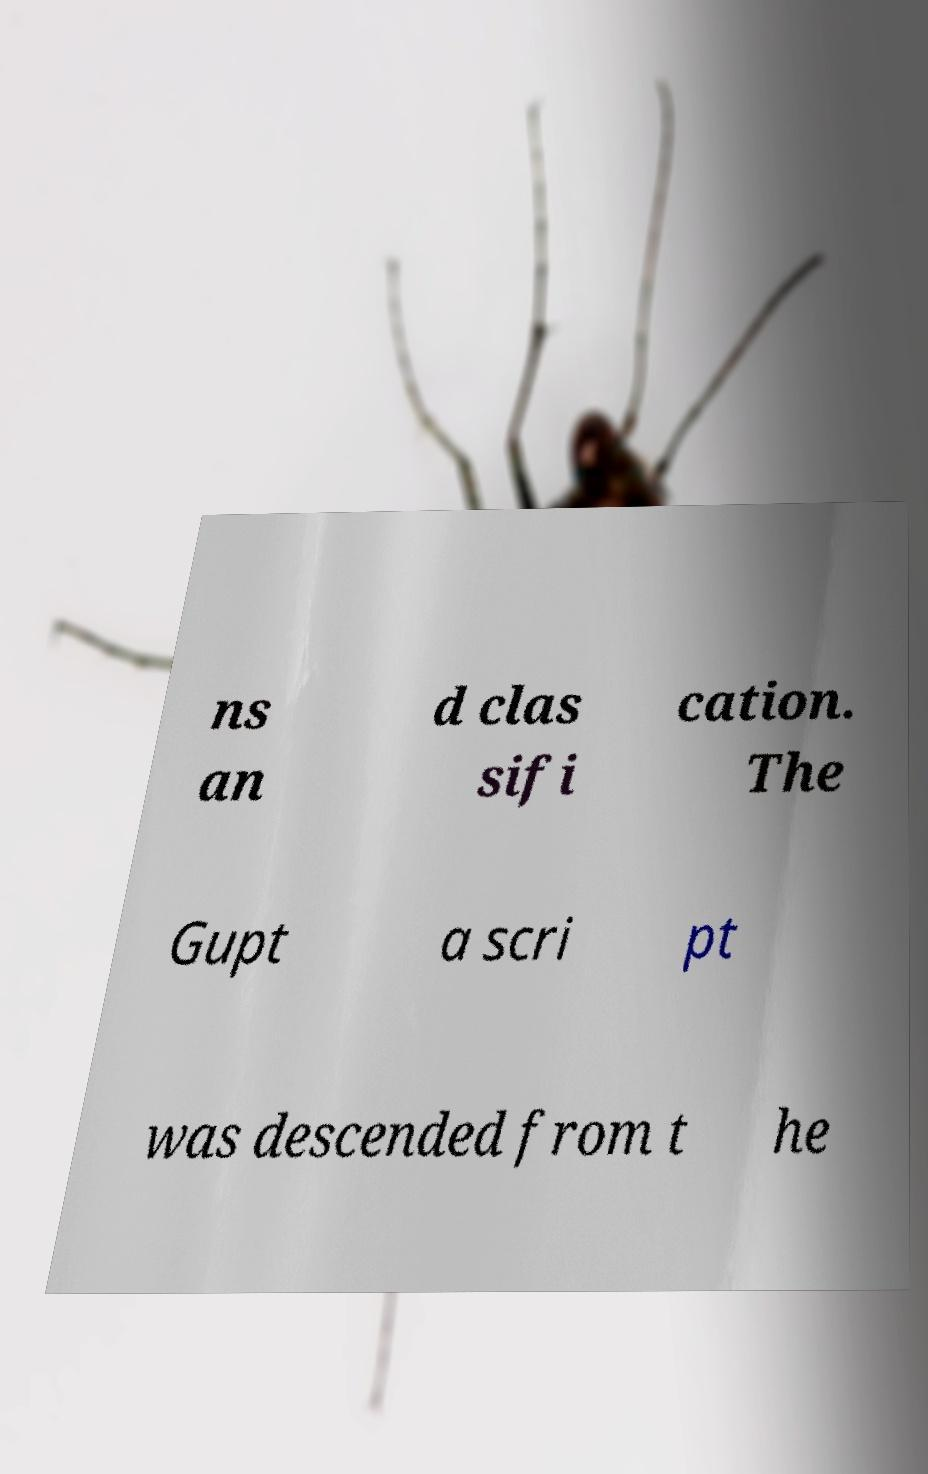Can you accurately transcribe the text from the provided image for me? ns an d clas sifi cation. The Gupt a scri pt was descended from t he 